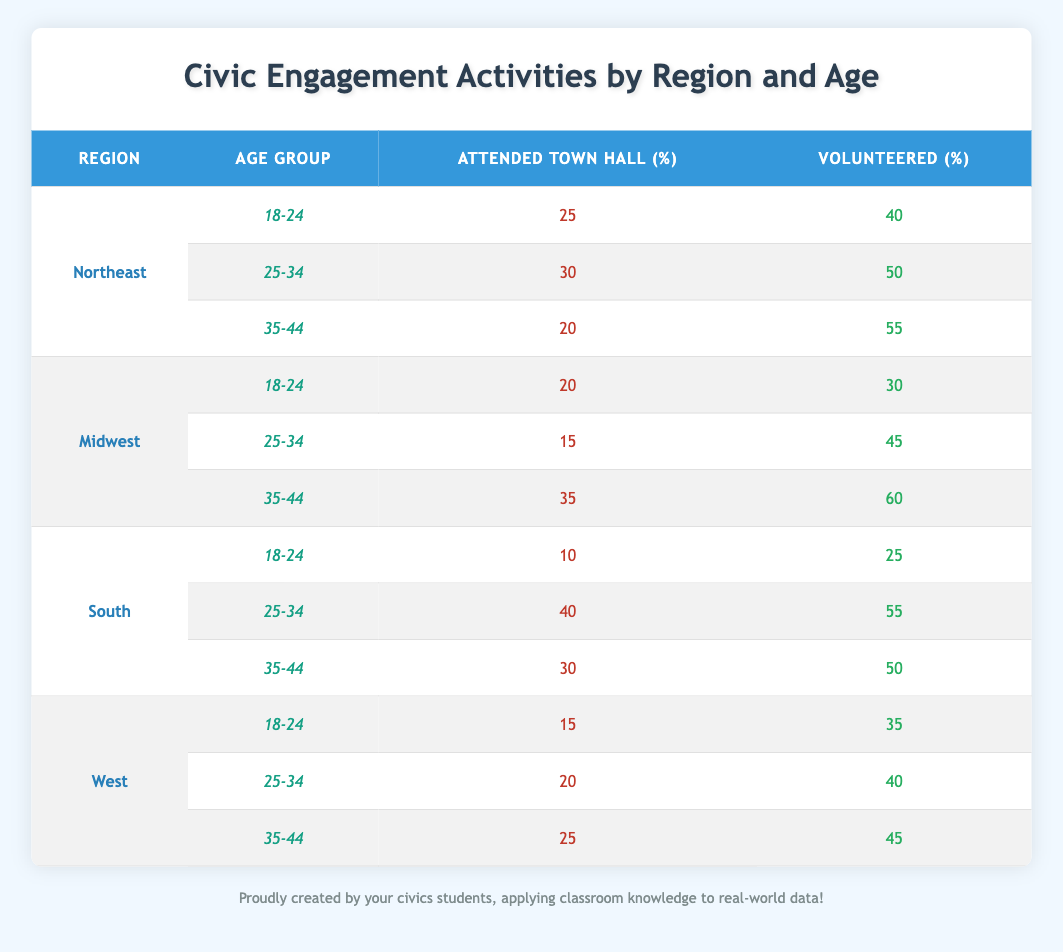What is the highest percentage of attendees at town hall meetings in the Northeast region? In the Northeast region, the highest percentage of attendance at town hall meetings is found in the 25-34 age group, which is 30%.
Answer: 30 Which age group volunteers the most in the Midwest region? To find this, the 'Volunteered' percentages for each age group in the Midwest must be compared. The 35-44 age group has the highest percentage at 60%.
Answer: 60 Is it true that younger individuals (18-24) in the South attended town hall meetings more than those in the Midwest? In the South, the percentage is 10% for the 18-24 age group, while in the Midwest, it is 20%. Thus, it is false that younger individuals in the South attended more.
Answer: No What is the average percentage of volunteering across all age groups in the West region? To calculate this, sum the volunteering percentages for the West (35, 40, 45) and divide by 3. The total is 120, so the average is 120/3 = 40%.
Answer: 40 How much more likely are individuals aged 25-34 in the South to volunteer compared to those aged 25-34 in the Northeast? The percentage of volunteers aged 25-34 in the South is 55%, while in the Northeast, it is 50%. The difference is 55 - 50 = 5%, indicating South volunteers 5% more.
Answer: 5 In which region and age group do individuals have the lowest attendance rate at town hall meetings? Looking at the attendance rates for all regions and age groups, the lowest attendance rate is found in the South for the 18-24 age group, which is only 10%.
Answer: South, 18-24 What is the total attendance percentage at town hall meetings for all age groups in the Northeast? Add the percentages for the Northeast: 25 + 30 + 20 = 75. Thus, the total attendance percentage for the Northeast is 75%.
Answer: 75 Do individuals aged 35-44 in the Midwest volunteer more than those aged 35-44 in the South? In the Midwest, the volunteering percentage for the 35-44 age group is 60%, while in the South, it is 50%. Therefore, it is true that they volunteer more in the Midwest.
Answer: Yes 